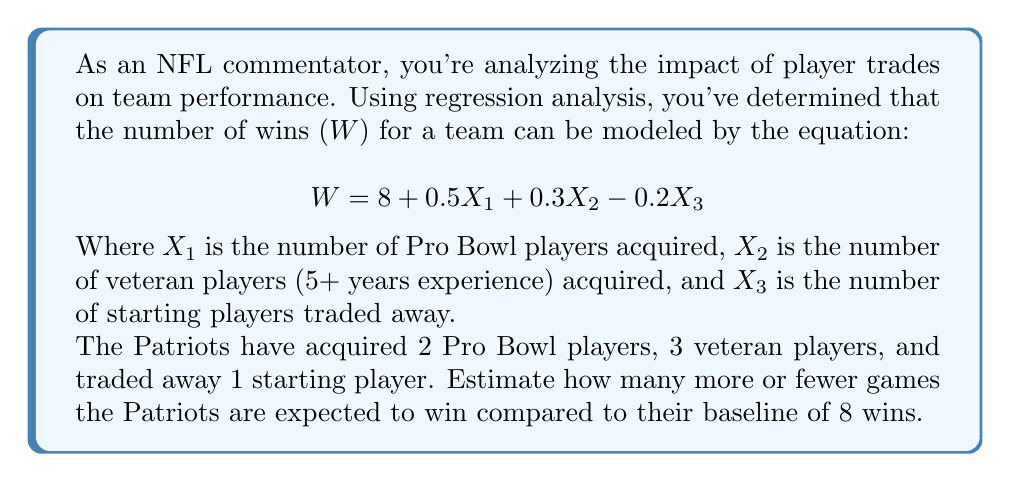Provide a solution to this math problem. To solve this problem, we need to follow these steps:

1) Recall the given regression equation:
   $$W = 8 + 0.5X_1 + 0.3X_2 - 0.2X_3$$

2) Identify the values for each variable:
   $X_1 = 2$ (Pro Bowl players acquired)
   $X_2 = 3$ (Veteran players acquired)
   $X_3 = 1$ (Starting players traded away)

3) Substitute these values into the equation:
   $$W = 8 + 0.5(2) + 0.3(3) - 0.2(1)$$

4) Solve the equation:
   $$W = 8 + 1 + 0.9 - 0.2$$
   $$W = 9.7$$

5) Calculate the difference from the baseline:
   $$\text{Difference} = 9.7 - 8 = 1.7$$

Therefore, based on this regression model, the Patriots are expected to win 1.7 more games compared to their baseline of 8 wins.
Answer: 1.7 more wins 